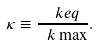<formula> <loc_0><loc_0><loc_500><loc_500>\kappa \equiv \frac { \ k e q } { \ k \max } .</formula> 